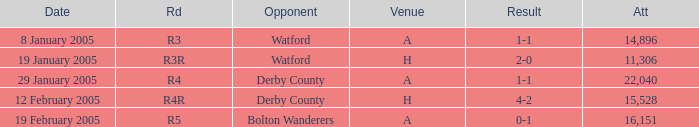What is the round of the game at venue H and opponent of Derby County? R4R. 